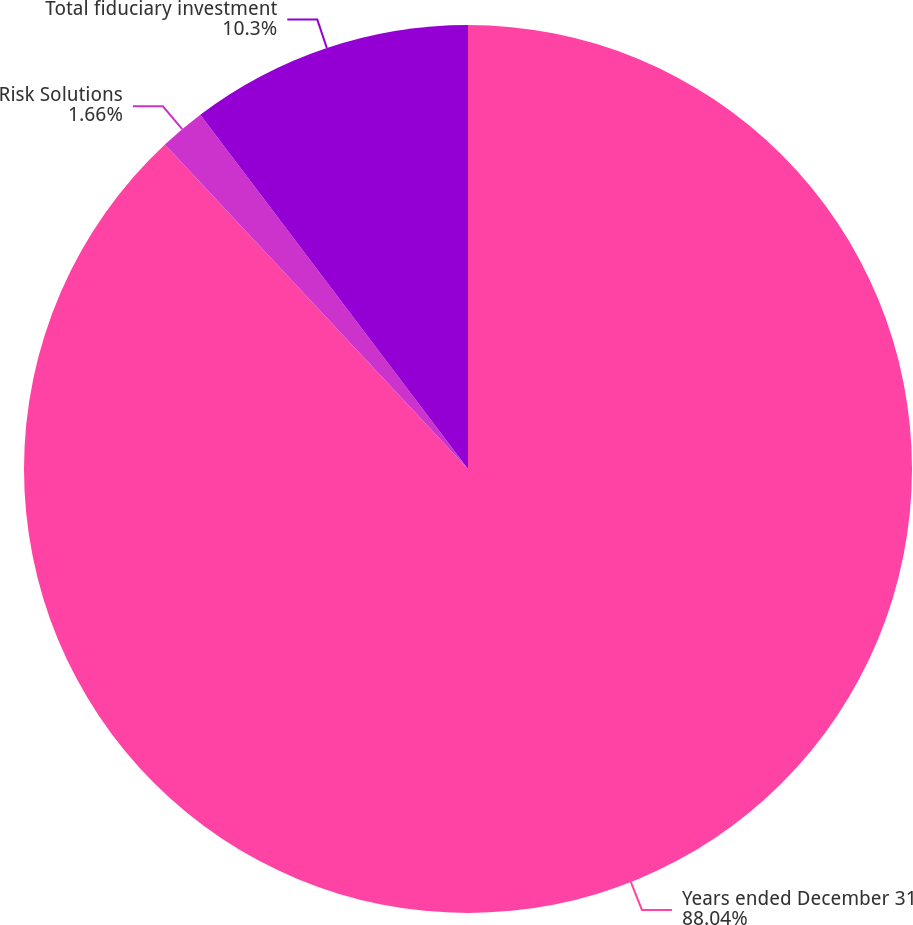Convert chart to OTSL. <chart><loc_0><loc_0><loc_500><loc_500><pie_chart><fcel>Years ended December 31<fcel>Risk Solutions<fcel>Total fiduciary investment<nl><fcel>88.04%<fcel>1.66%<fcel>10.3%<nl></chart> 